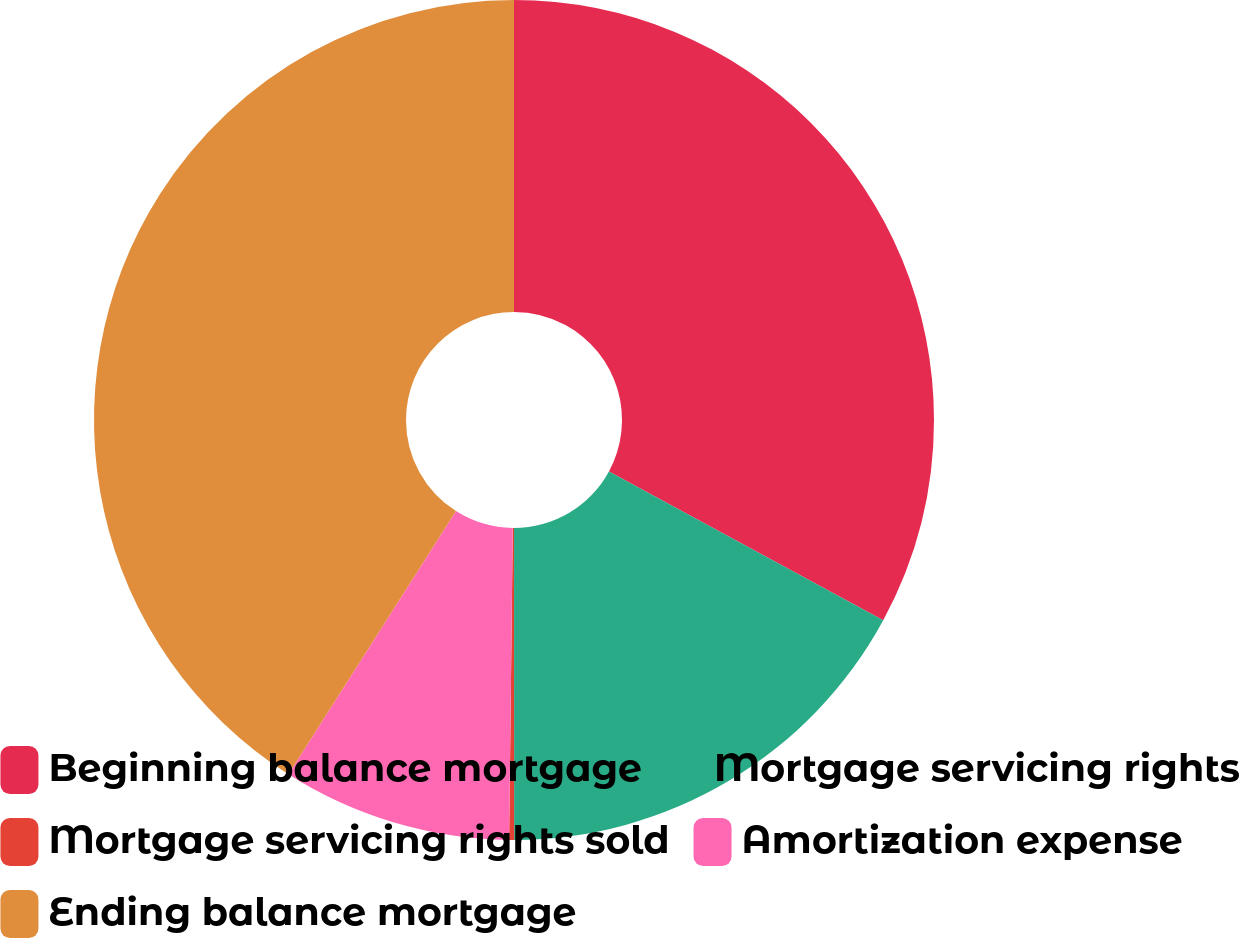Convert chart. <chart><loc_0><loc_0><loc_500><loc_500><pie_chart><fcel>Beginning balance mortgage<fcel>Mortgage servicing rights<fcel>Mortgage servicing rights sold<fcel>Amortization expense<fcel>Ending balance mortgage<nl><fcel>32.91%<fcel>17.09%<fcel>0.19%<fcel>8.84%<fcel>40.98%<nl></chart> 